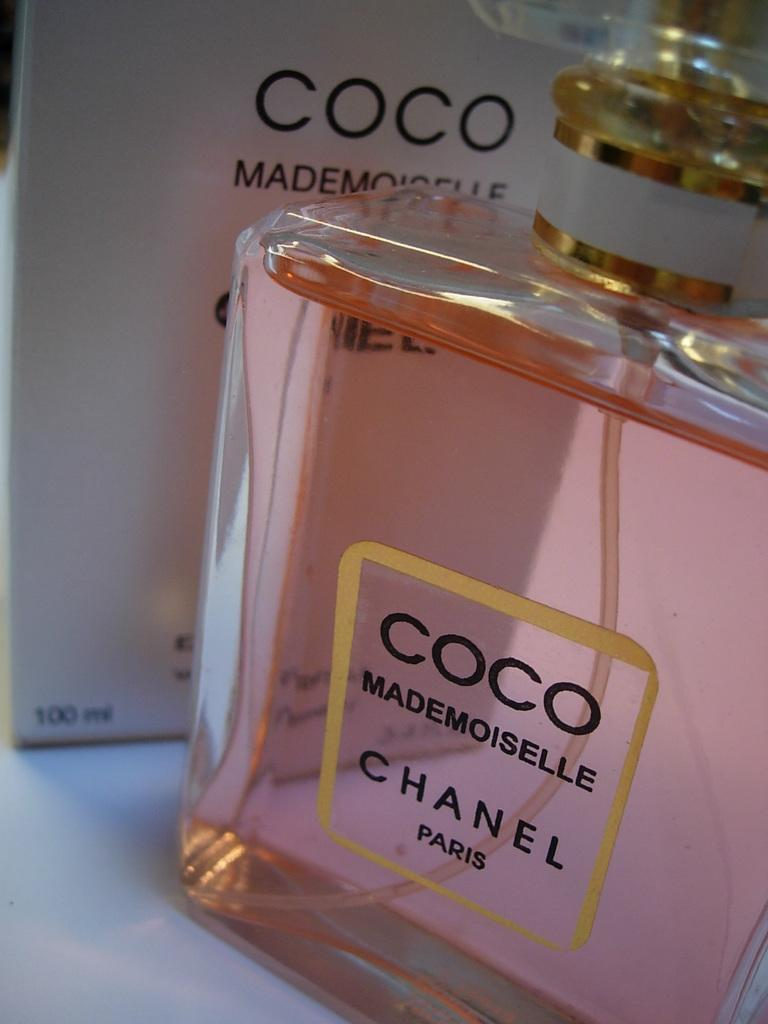<image>
Present a compact description of the photo's key features. The glass perfume bottle has the brand nae Chanel on it 